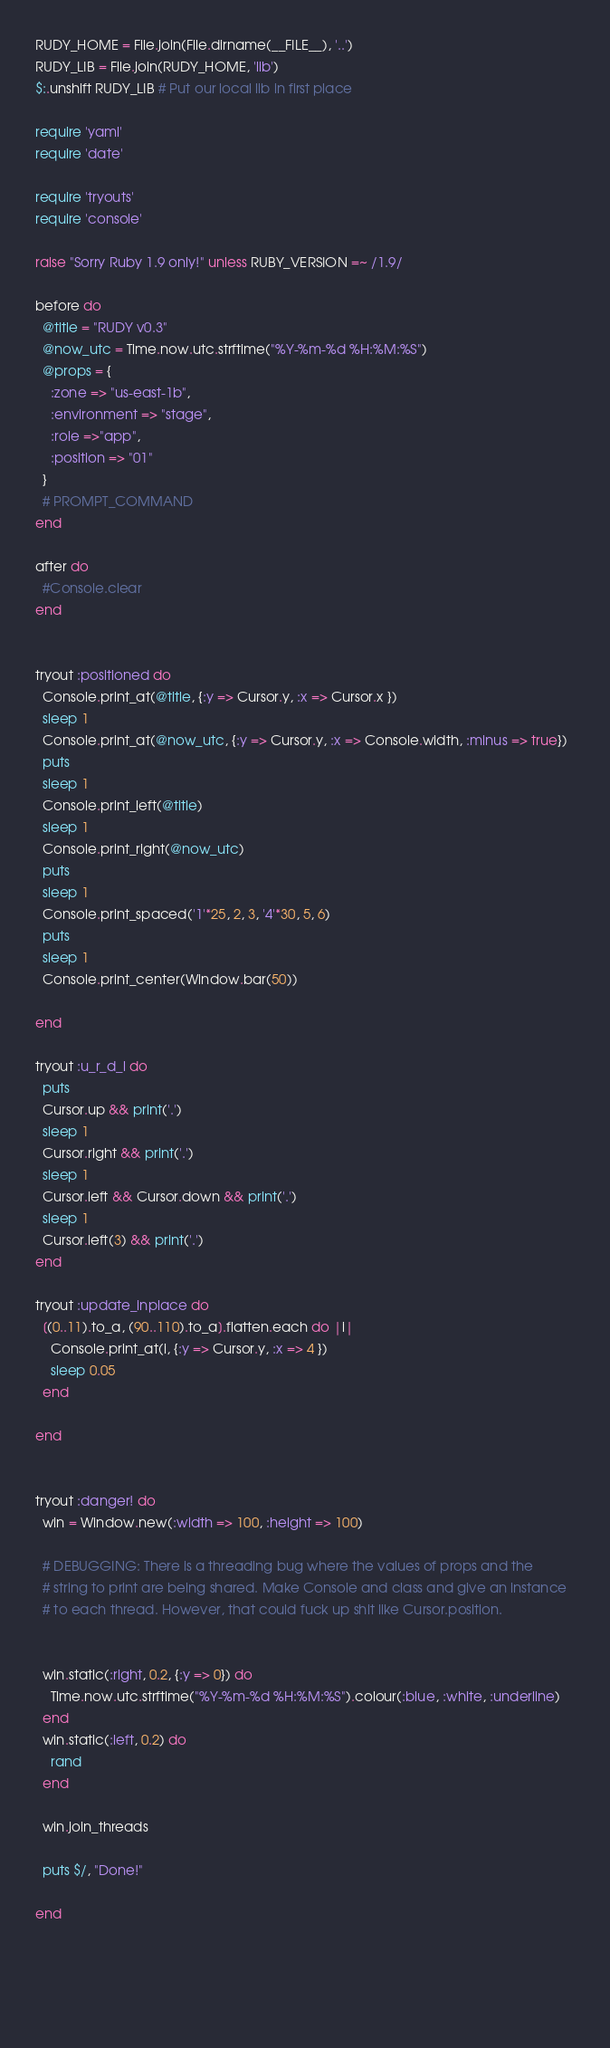Convert code to text. <code><loc_0><loc_0><loc_500><loc_500><_Ruby_>RUDY_HOME = File.join(File.dirname(__FILE__), '..')
RUDY_LIB = File.join(RUDY_HOME, 'lib')
$:.unshift RUDY_LIB # Put our local lib in first place

require 'yaml'
require 'date'

require 'tryouts'
require 'console'

raise "Sorry Ruby 1.9 only!" unless RUBY_VERSION =~ /1.9/

before do
  @title = "RUDY v0.3"
  @now_utc = Time.now.utc.strftime("%Y-%m-%d %H:%M:%S")
  @props = {
    :zone => "us-east-1b", 
    :environment => "stage",
    :role =>"app", 
    :position => "01"
  }
  # PROMPT_COMMAND
end

after do 
  #Console.clear
end


tryout :positioned do
  Console.print_at(@title, {:y => Cursor.y, :x => Cursor.x })
  sleep 1
  Console.print_at(@now_utc, {:y => Cursor.y, :x => Console.width, :minus => true})  
  puts
  sleep 1
  Console.print_left(@title)
  sleep 1
  Console.print_right(@now_utc)
  puts
  sleep 1
  Console.print_spaced('1'*25, 2, 3, '4'*30, 5, 6)
  puts
  sleep 1
  Console.print_center(Window.bar(50))
  
end

tryout :u_r_d_l do
  puts
  Cursor.up && print('.') 
  sleep 1
  Cursor.right && print('.')
  sleep 1
  Cursor.left && Cursor.down && print('.')
  sleep 1
  Cursor.left(3) && print('.')
end

tryout :update_inplace do
  [(0..11).to_a, (90..110).to_a].flatten.each do |i|
    Console.print_at(i, {:y => Cursor.y, :x => 4 })
    sleep 0.05
  end
  
end


tryout :danger! do
  win = Window.new(:width => 100, :height => 100)
  
  # DEBUGGING: There is a threading bug where the values of props and the
  # string to print are being shared. Make Console and class and give an instance
  # to each thread. However, that could fuck up shit like Cursor.position. 
  
  
  win.static(:right, 0.2, {:y => 0}) do 
    Time.now.utc.strftime("%Y-%m-%d %H:%M:%S").colour(:blue, :white, :underline)
  end
  win.static(:left, 0.2) do 
    rand
  end
  
  win.join_threads
  
  puts $/, "Done!"
  
end


  
  
</code> 